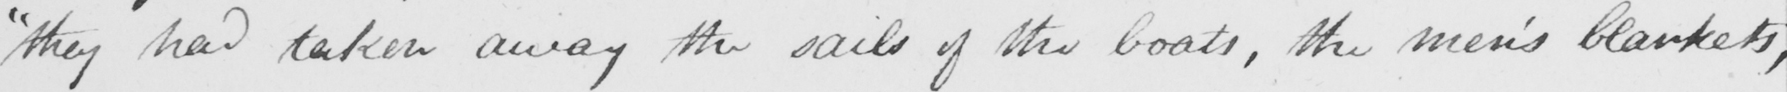Please transcribe the handwritten text in this image. " they had taken away the sails of the boats , the men ' s blankets , 